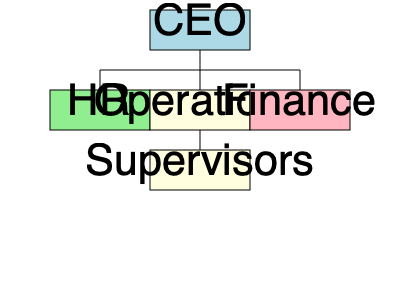Based on the organizational chart, which department would you most likely collaborate with for employee management and compliance issues, and who does this department report to directly? To answer this question, we need to analyze the organizational chart step-by-step:

1. Identify the departments: The chart shows three main departments - HR, Operations, and Finance.

2. Consider the persona: As a department supervisor who relies on HR for employee management and compliance, we need to focus on the HR department.

3. Locate the HR department: The HR department is on the left side of the chart, represented by a light green box.

4. Determine HR's reporting structure: The HR department has a line connecting it directly to the top of the chart.

5. Identify who HR reports to: Following the line upwards, we can see that HR reports directly to the CEO, who is at the top of the organizational structure.

6. Confirm the collaboration: As a department supervisor dealing with employee management and compliance, you would indeed work closely with the HR department.

Therefore, the department you would most likely collaborate with is HR, and this department reports directly to the CEO.
Answer: HR department, reporting to the CEO 